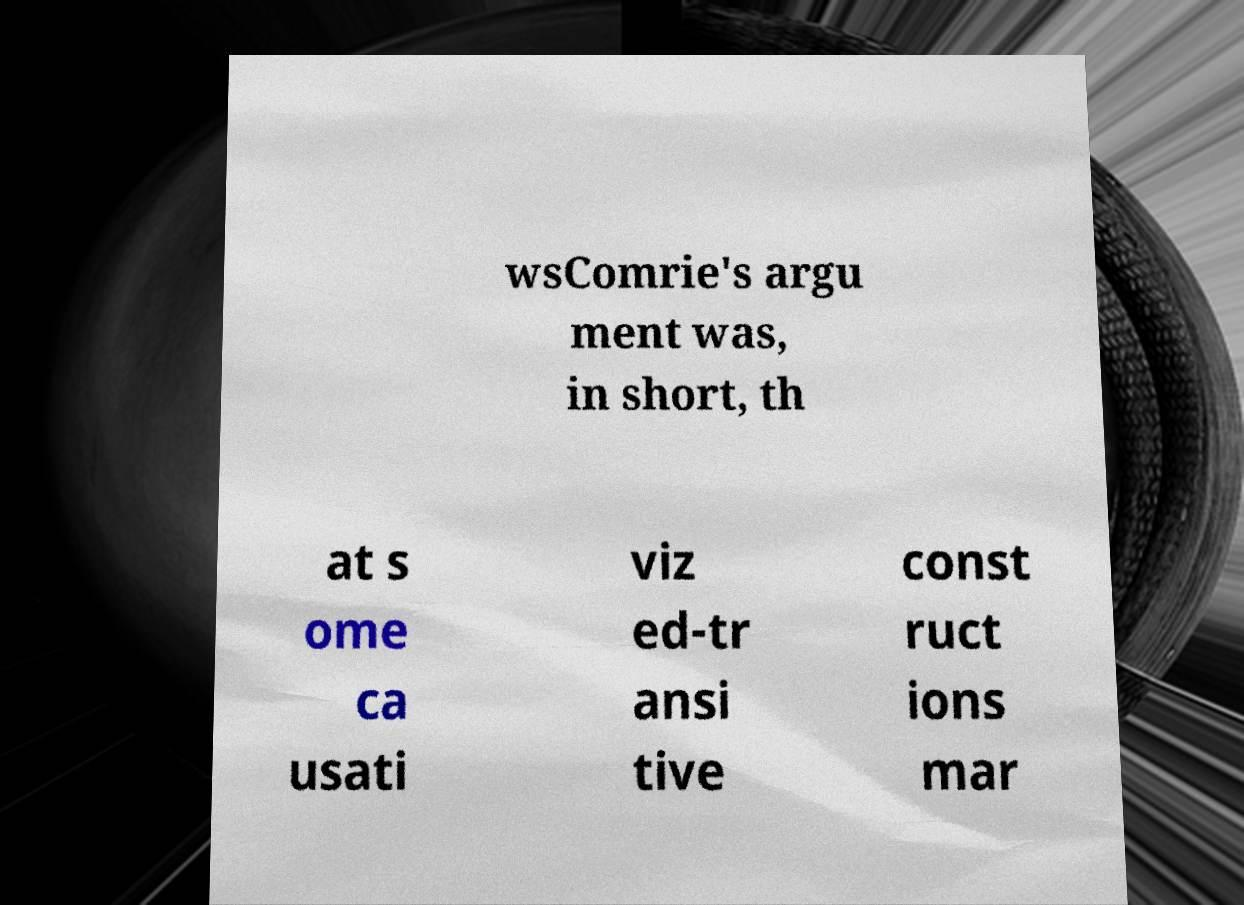Please identify and transcribe the text found in this image. wsComrie's argu ment was, in short, th at s ome ca usati viz ed-tr ansi tive const ruct ions mar 